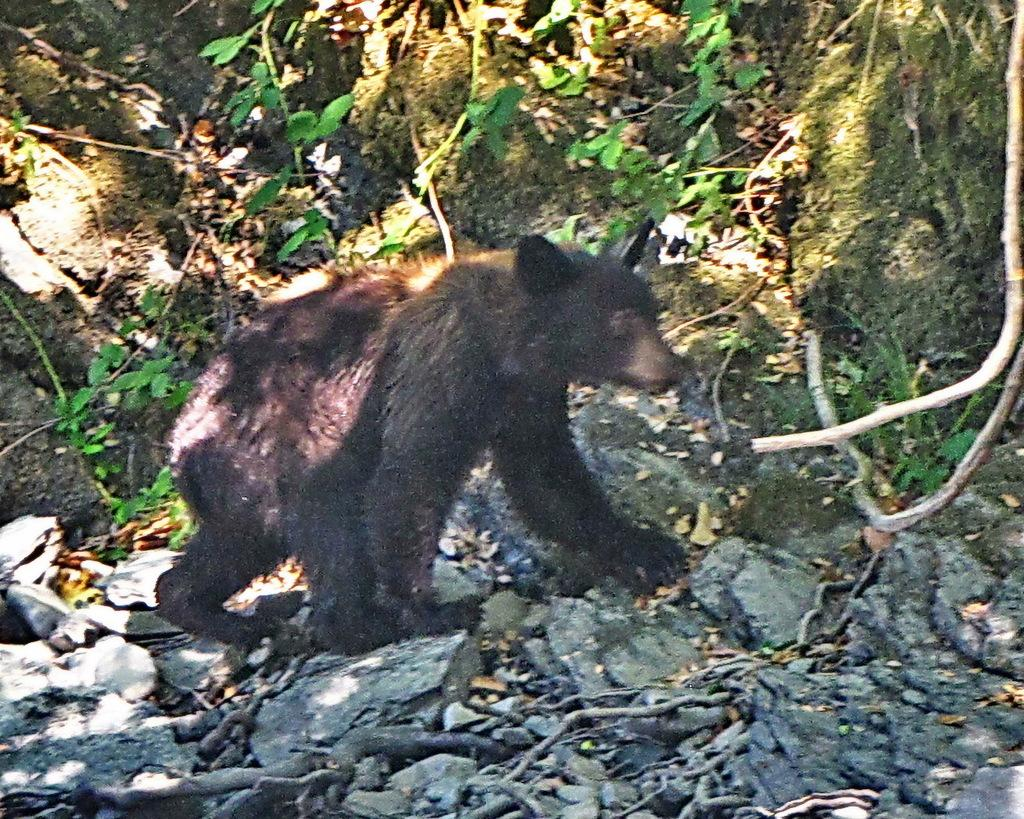What is the main subject in the center of the image? There is an animal in the center of the image. What can be seen at the bottom of the image? There are stones, dry grass, wooden sticks, and scrap present at the bottom of the image. What is visible in the background of the image? There are plants and sand visible in the background of the image. What type of bean is being used to fix the error in the image? There is no bean or error present in the image. Is there a bottle visible in the image? No, there is no bottle visible in the image. 